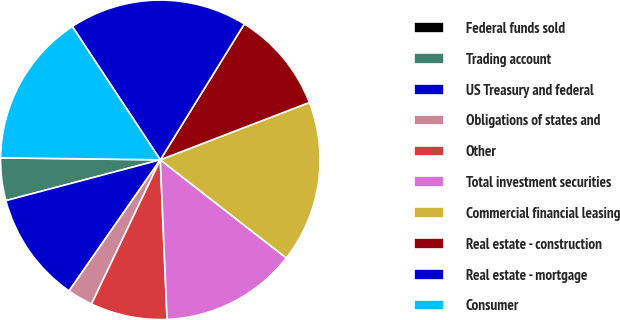<chart> <loc_0><loc_0><loc_500><loc_500><pie_chart><fcel>Federal funds sold<fcel>Trading account<fcel>US Treasury and federal<fcel>Obligations of states and<fcel>Other<fcel>Total investment securities<fcel>Commercial financial leasing<fcel>Real estate - construction<fcel>Real estate - mortgage<fcel>Consumer<nl><fcel>0.0%<fcel>4.31%<fcel>11.21%<fcel>2.59%<fcel>7.76%<fcel>13.79%<fcel>16.38%<fcel>10.34%<fcel>18.1%<fcel>15.52%<nl></chart> 